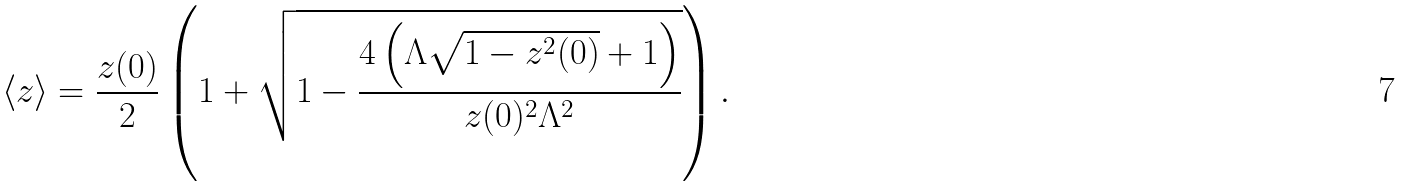Convert formula to latex. <formula><loc_0><loc_0><loc_500><loc_500>\left \langle z \right \rangle = \frac { z ( 0 ) } 2 \left ( 1 + \sqrt { 1 - \frac { 4 \left ( \Lambda \sqrt { 1 - z ^ { 2 } ( 0 ) } + 1 \right ) } { z ( 0 ) ^ { 2 } \Lambda ^ { 2 } } } \right ) .</formula> 